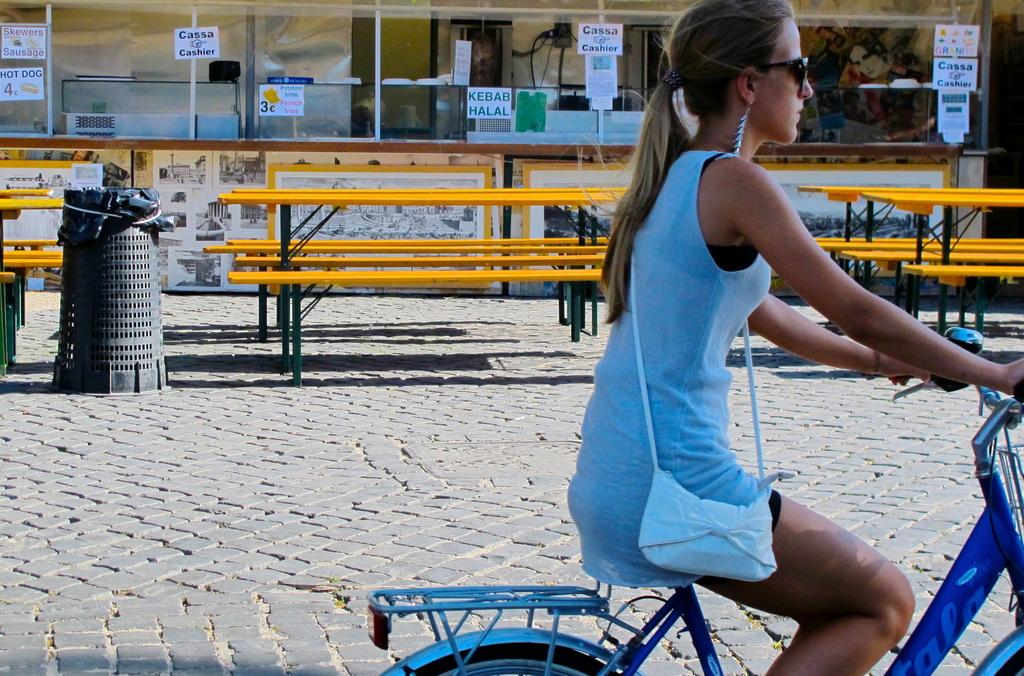Who is the main subject in the image? There is a woman in the image. What is the woman doing in the image? The woman is riding a bicycle. Where is the bicycle located in the image? The bicycle is on a road. What other objects can be seen in the image? There are benches and a counter in the image. What type of wine is the woman drinking while riding the bicycle in the image? There is no wine present in the image; the woman is riding a bicycle on a road. 